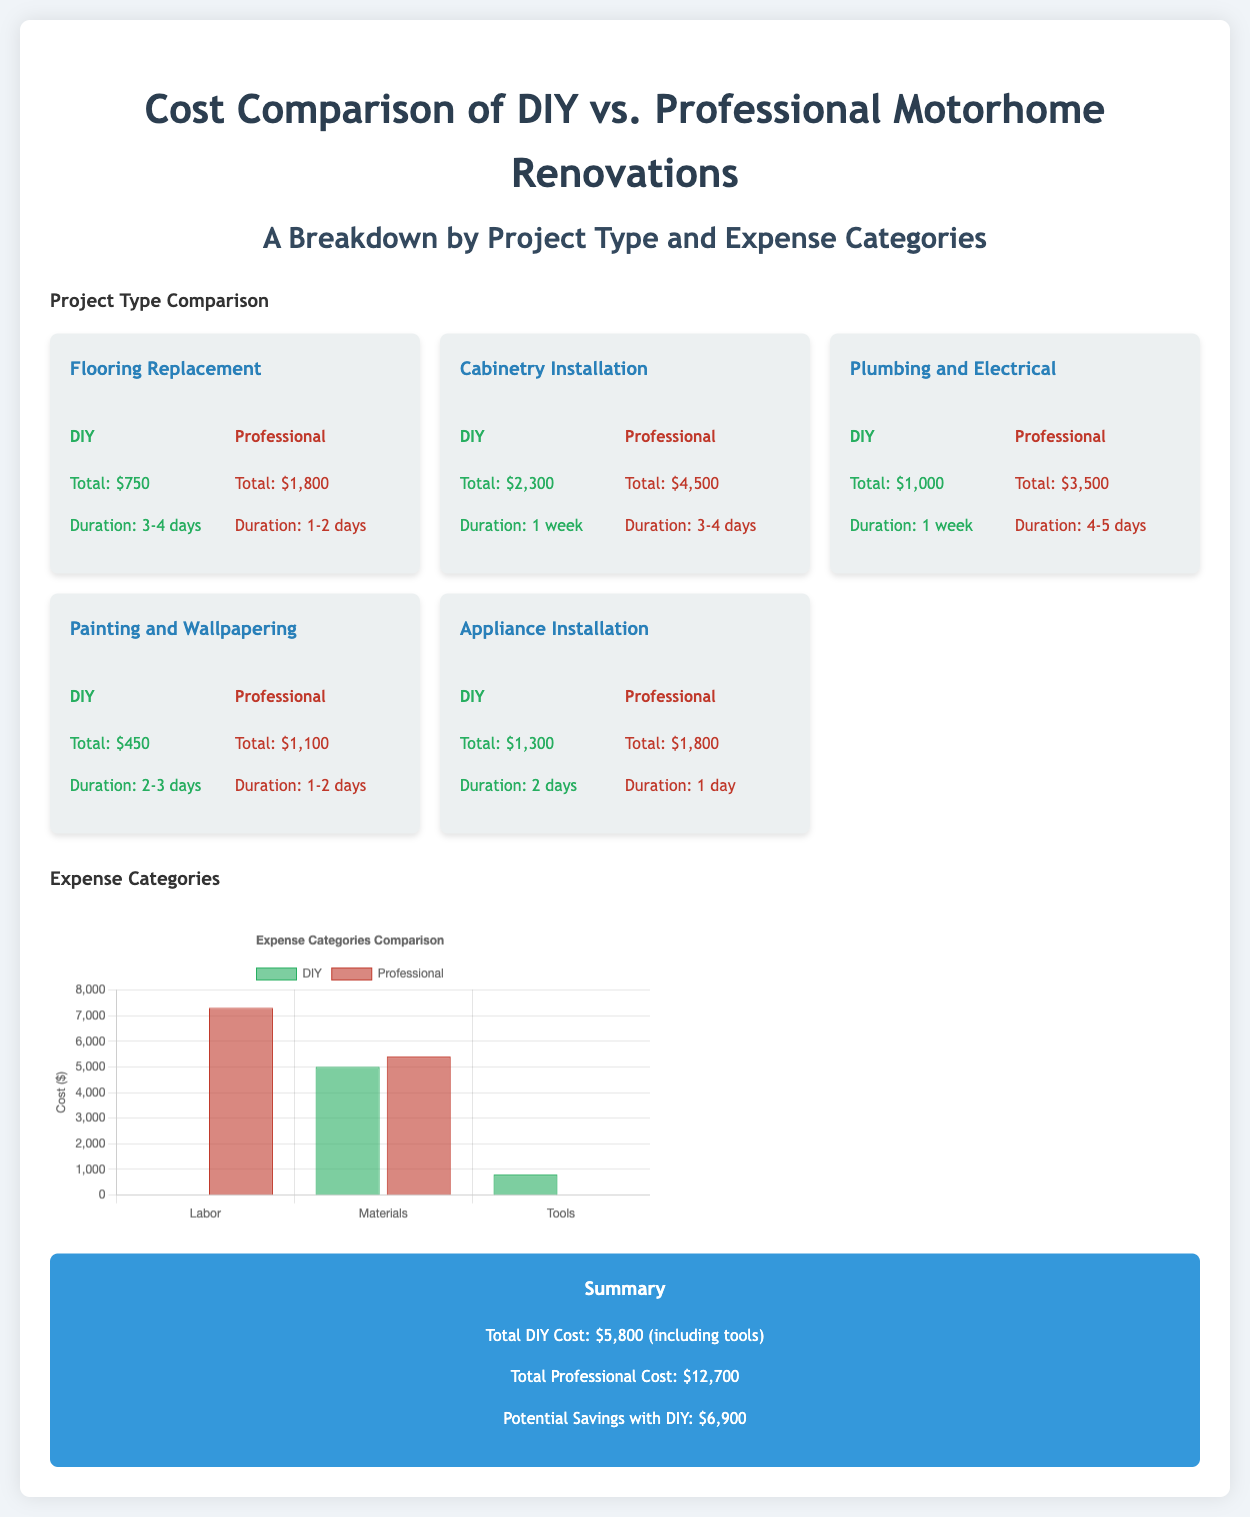What is the total cost for DIY flooring replacement? The total cost for DIY flooring replacement is specified in the document as $750.
Answer: $750 What is the duration for professional cabinetry installation? The duration for professional cabinetry installation is mentioned as 3-4 days in the document.
Answer: 3-4 days How much can be saved by choosing DIY over professional rebuilding? The potential savings with DIY over professional costs is provided as $6,900 in the summary.
Answer: $6,900 What are the total professional costs for all projects combined? The total professional cost for all projects is stated as $12,700 in the summary.
Answer: $12,700 Which expense category has the highest cost for professionals? The expense category with the highest cost for professionals is Labor, which is $7,300.
Answer: Labor How long does it take to DIY appliance installation? The duration to DIY appliance installation is noted as 2 days in the document.
Answer: 2 days What is the total DIY cost including tools? The total DIY cost including tools is detailed as $5,800 in the summary.
Answer: $5,800 Which project type has the highest DIY costs? The project type with the highest DIY costs is Cabinetry Installation at $2,300.
Answer: Cabinetry Installation What percentage of total costs for professionals is attributed to materials? The total professional cost for materials is $5,400, which is about 42.5% of $12,700 (not directly stated).
Answer: 42.5% How much does professional painting and wallpapering cost? The professional cost for painting and wallpapering is detailed as $1,100 in the document.
Answer: $1,100 